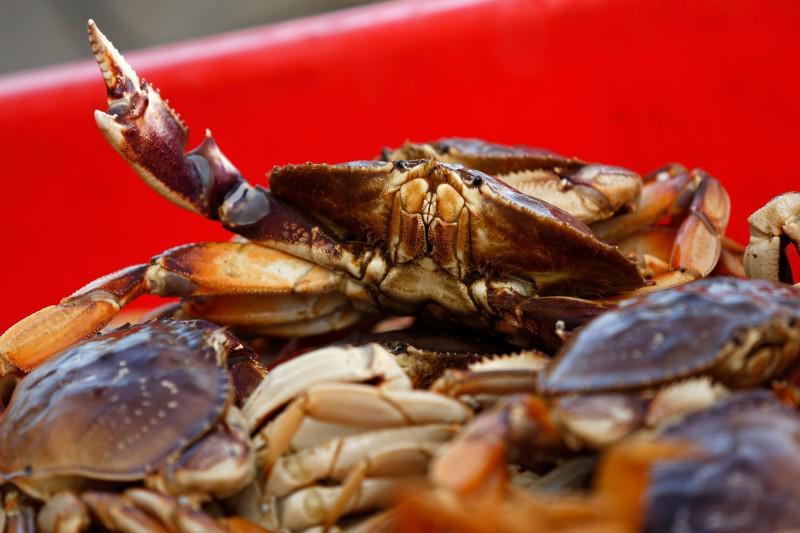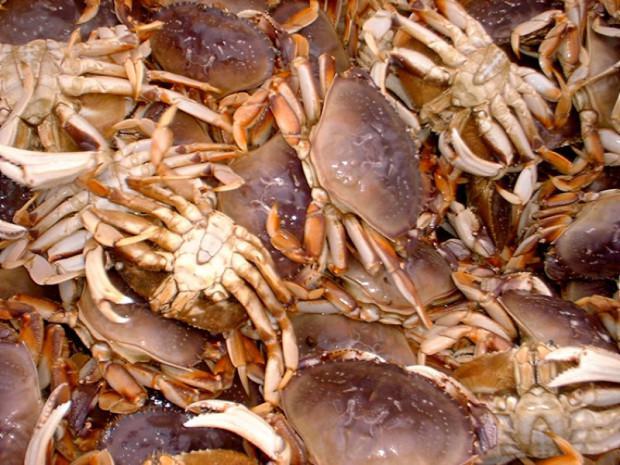The first image is the image on the left, the second image is the image on the right. Considering the images on both sides, is "One image includes a camera-facing crab with at least one front claw raised and the edge of a red container behind it." valid? Answer yes or no. Yes. 